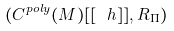Convert formula to latex. <formula><loc_0><loc_0><loc_500><loc_500>( C ^ { p o l y } ( M ) [ [ \ h ] ] , R _ { \Pi } )</formula> 